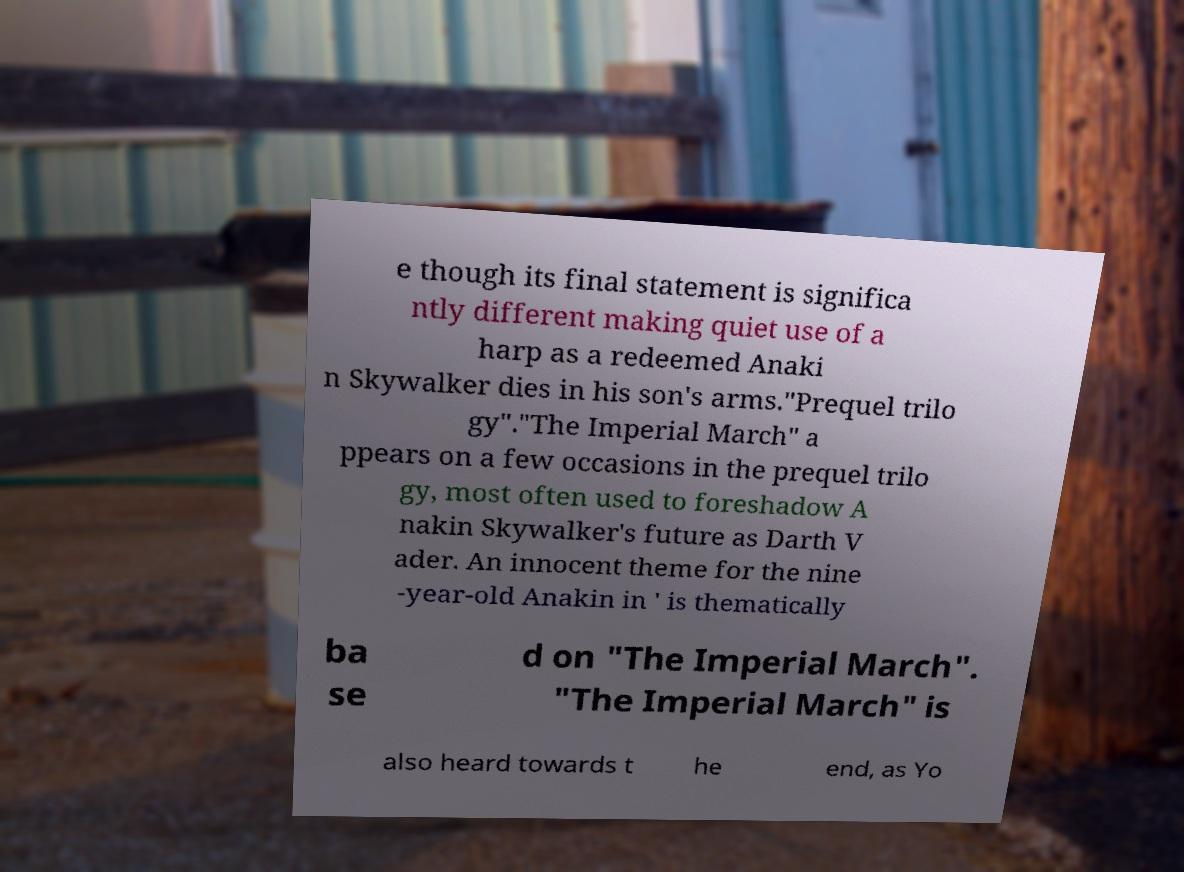Could you assist in decoding the text presented in this image and type it out clearly? e though its final statement is significa ntly different making quiet use of a harp as a redeemed Anaki n Skywalker dies in his son's arms."Prequel trilo gy"."The Imperial March" a ppears on a few occasions in the prequel trilo gy, most often used to foreshadow A nakin Skywalker's future as Darth V ader. An innocent theme for the nine -year-old Anakin in ' is thematically ba se d on "The Imperial March". "The Imperial March" is also heard towards t he end, as Yo 